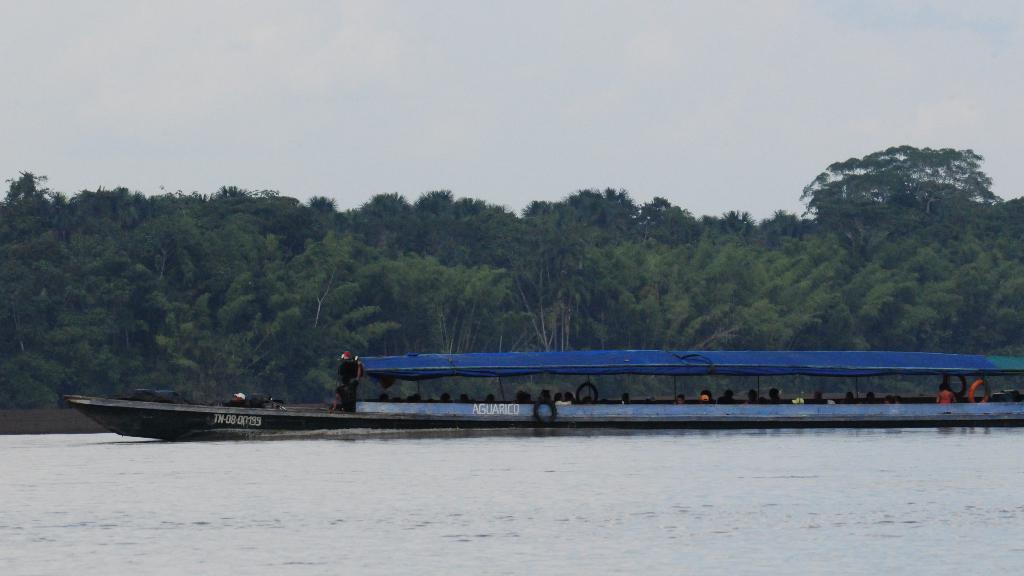How would you summarize this image in a sentence or two? In this image I can see the water , a boat which is black, white and blue in color on the surface of the water and few persons in the boat. In the background I can see few trees which are green in color and the sky. 